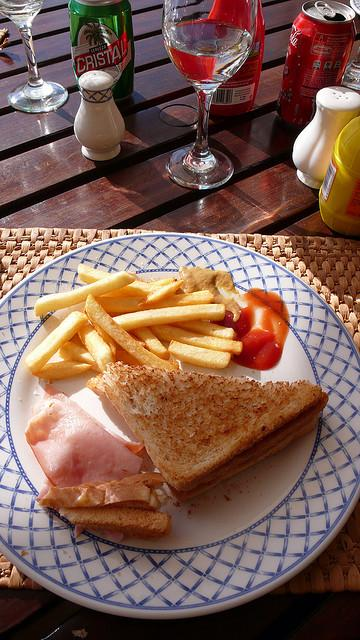Where was this sandwich likely cooked?

Choices:
A) grill
B) oven
C) microwave
D) fire grill 